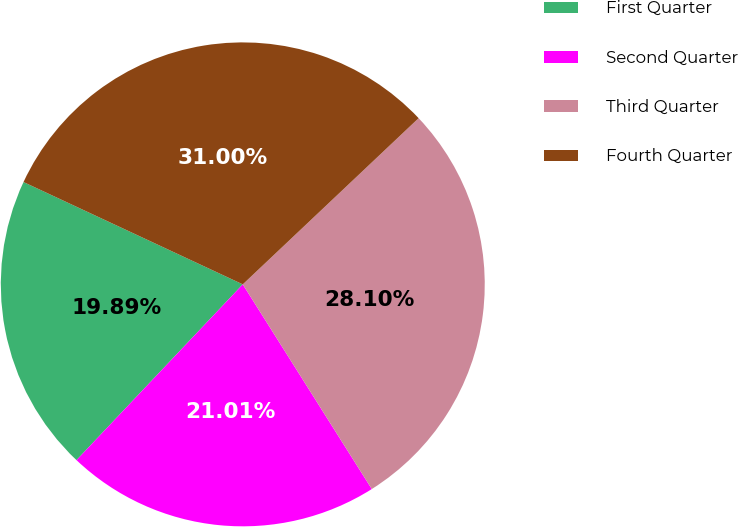Convert chart to OTSL. <chart><loc_0><loc_0><loc_500><loc_500><pie_chart><fcel>First Quarter<fcel>Second Quarter<fcel>Third Quarter<fcel>Fourth Quarter<nl><fcel>19.89%<fcel>21.01%<fcel>28.1%<fcel>31.0%<nl></chart> 